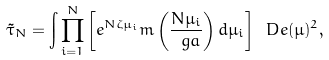<formula> <loc_0><loc_0><loc_500><loc_500>\tilde { \tau } _ { N } = \int \prod _ { i = 1 } ^ { N } \left [ e ^ { N \zeta \mu _ { i } } m \left ( \frac { N \mu _ { i } } { \ g a } \right ) d \mu _ { i } \right ] \ D e ( \mu ) ^ { 2 } ,</formula> 